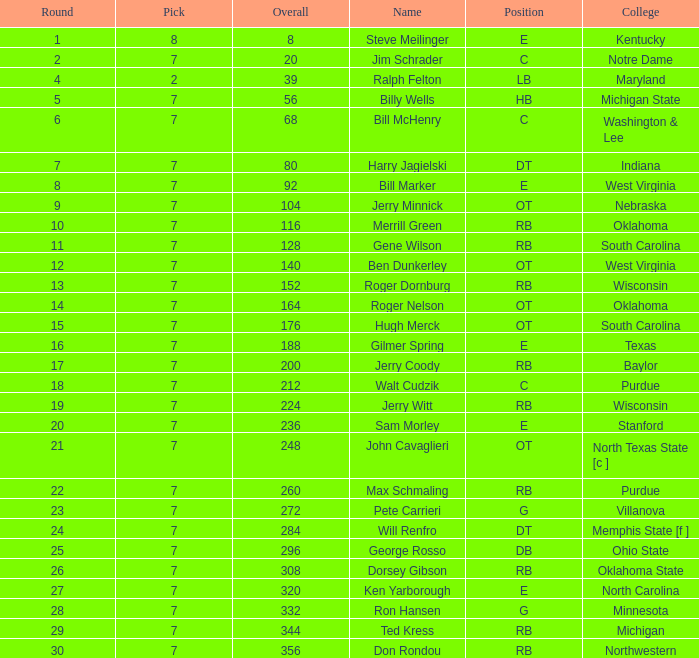What pick did George Rosso get drafted when the overall was less than 296? 0.0. 